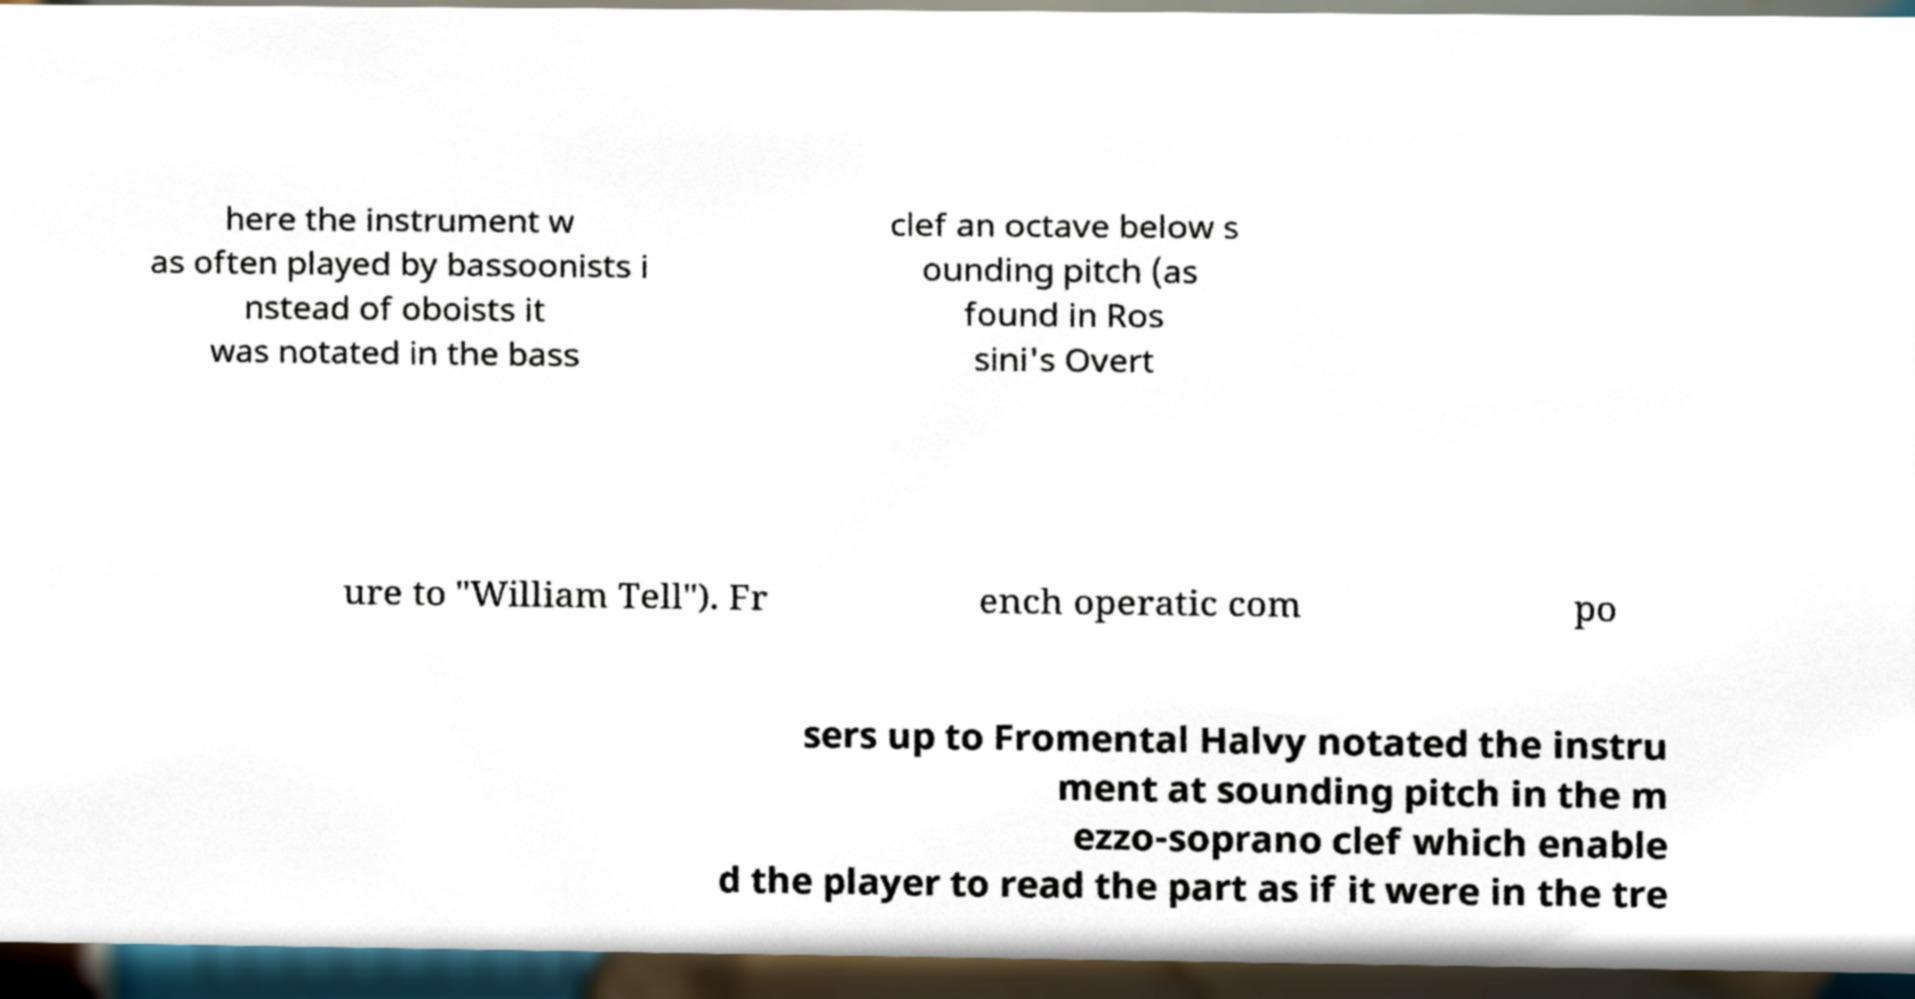Could you assist in decoding the text presented in this image and type it out clearly? here the instrument w as often played by bassoonists i nstead of oboists it was notated in the bass clef an octave below s ounding pitch (as found in Ros sini's Overt ure to "William Tell"). Fr ench operatic com po sers up to Fromental Halvy notated the instru ment at sounding pitch in the m ezzo-soprano clef which enable d the player to read the part as if it were in the tre 